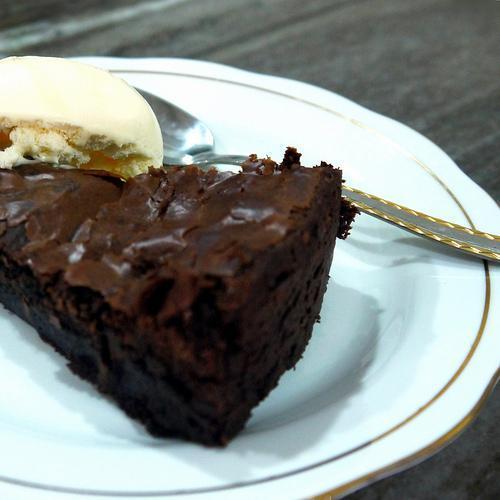How many spoons are there?
Give a very brief answer. 1. 